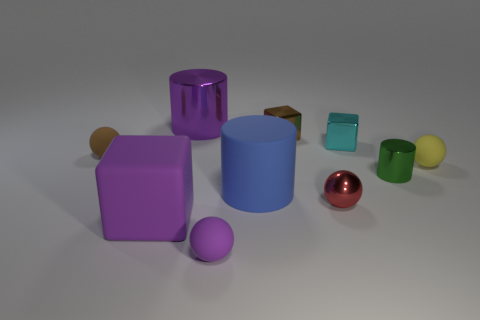Subtract all green balls. Subtract all blue cylinders. How many balls are left? 4 Subtract all cylinders. How many objects are left? 7 Subtract 0 blue cubes. How many objects are left? 10 Subtract all big green cylinders. Subtract all tiny brown balls. How many objects are left? 9 Add 5 red metallic spheres. How many red metallic spheres are left? 6 Add 9 yellow balls. How many yellow balls exist? 10 